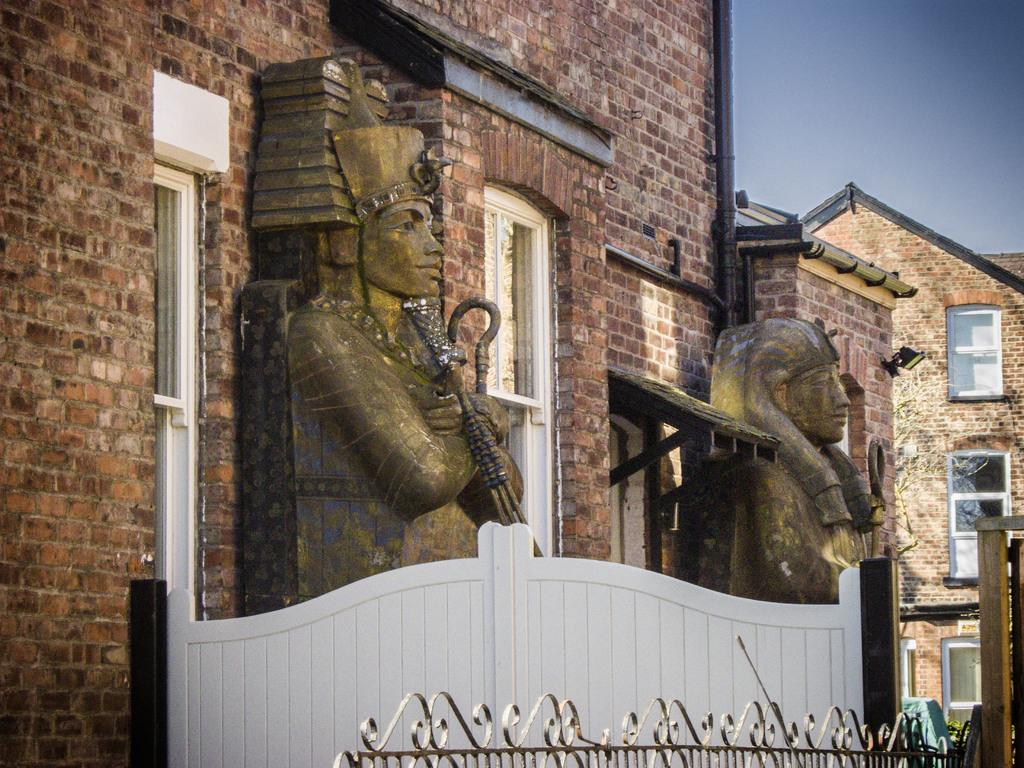What type of structures can be seen in the image? There are buildings in the image. What decorative elements are present on the buildings? There are statues on the buildings. What is visible at the top of the image? The sky is visible at the top of the image. What type of silk is draped around the statues on the buildings? There is no silk present in the image; the statues are not draped in any fabric. 